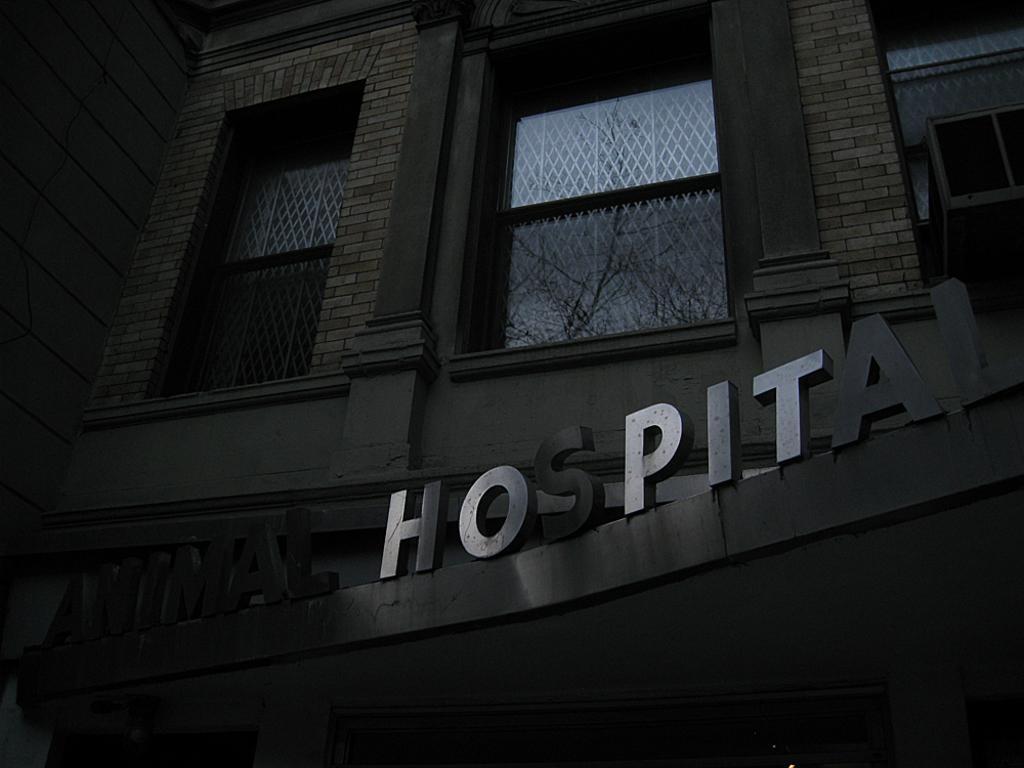How would you summarize this image in a sentence or two? This is a picture of a animal hospital with windows and air conditioner. 